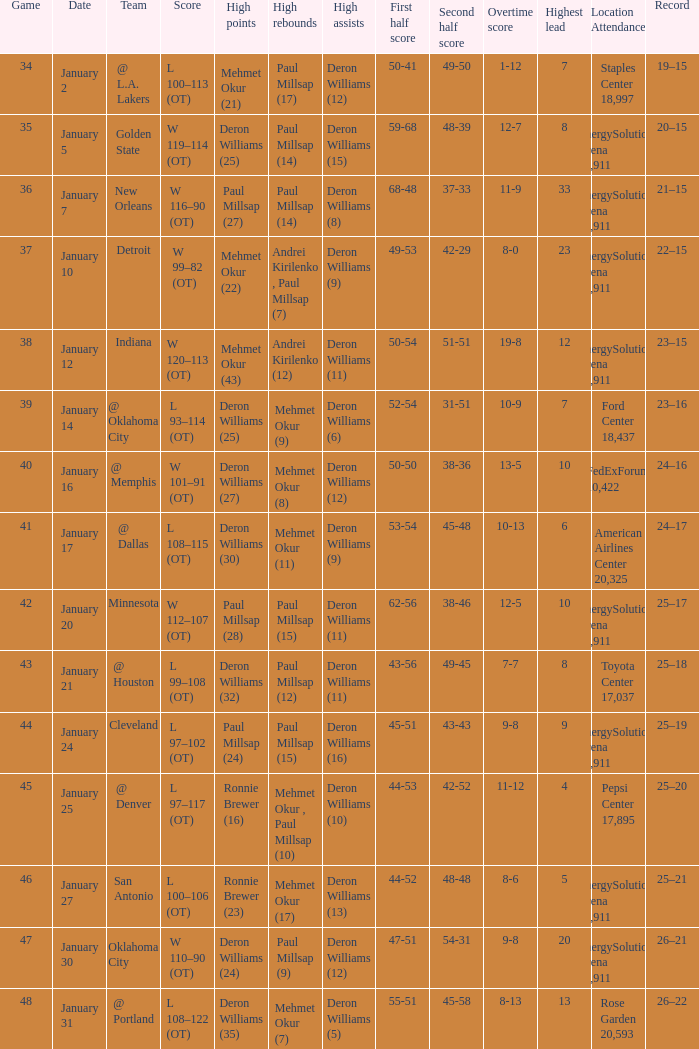What was the score of Game 48? L 108–122 (OT). 